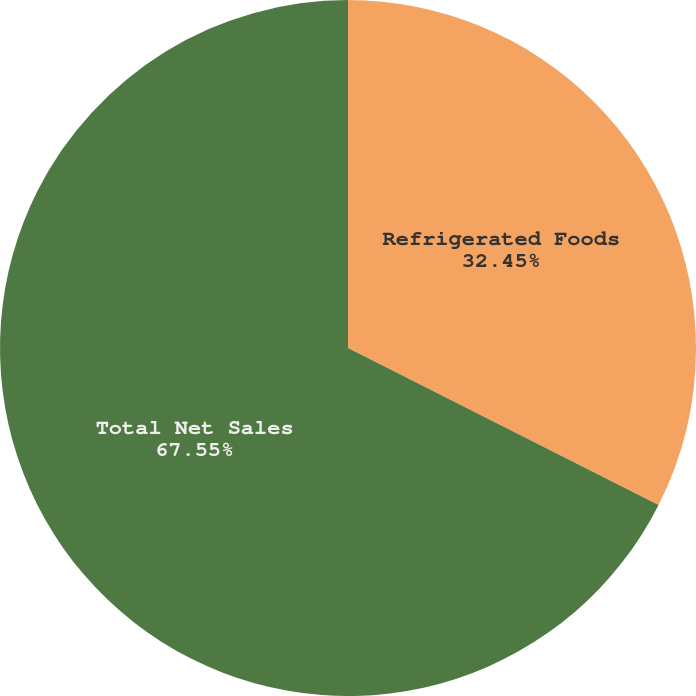Convert chart to OTSL. <chart><loc_0><loc_0><loc_500><loc_500><pie_chart><fcel>Refrigerated Foods<fcel>Total Net Sales<nl><fcel>32.45%<fcel>67.55%<nl></chart> 